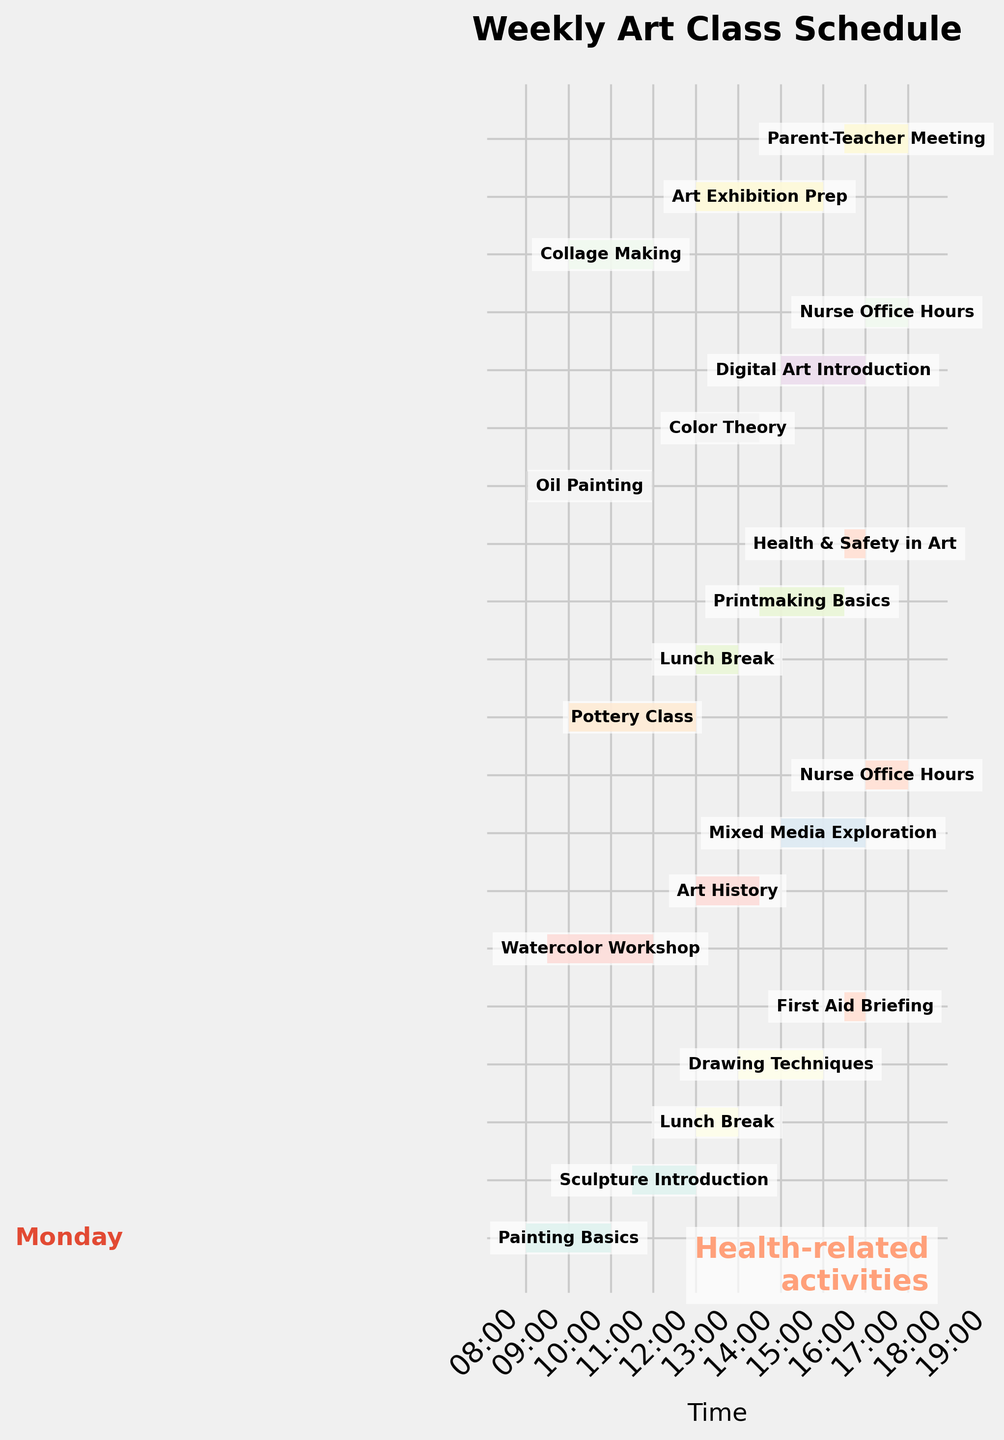What is the title of the figure? The title is typically placed at the top of the figure and describes what the figure represents. Here, the title is clearly stated.
Answer: Weekly Art Class Schedule On which days does the 'Nurse Office Hours' activity occur? We need to locate the 'Nurse Office Hours' bars on the chart and see on which days they are plotted.
Answer: Tuesday, Thursday What is the duration of the 'Pottery Class'? By looking at the length of the bar associated with 'Pottery Class' and the time labels on the x-axis, we can determine its length. The start time is 10:00, and the end time is 13:00.
Answer: 3 hours Which day has the highest number of activities? To determine this, count the number of bars on each day and compare.
Answer: Monday Which activity has the shortest duration? Find the smallest bar length by visually inspecting all the activities. For exact duration, refer to the time labels. 'First Aid Briefing' and 'Health & Safety in Art' have a duration of 0.5 hours each.
Answer: First Aid Briefing and Health & Safety in Art How much total time is allocated for 'health-related activities'? We need to add the durations of 'First Aid Briefing', 'Nurse Office Hours' (both days), and 'Health & Safety in Art': 0.5 + 1 + 1 + 0.5 = 3 hours.
Answer: 3 hours Which activity starts the earliest in the week? Identify the activity with the earliest start time by looking at the leftmost bars of the chart. 'Painting Basics' at 09:00 on Monday is the earliest.
Answer: Painting Basics Does 'Art Exhibition Prep' overlap with any other activity? Check if the 'Art Exhibition Prep' bar intersects with any other bars on Friday. There's no intersection between this and other Friday activities.
Answer: No What is the average duration of all activities on Tuesday? Calculate the average duration: (2.5 + 1.5 + 2 + 1) / 4 = 1.75 hours.
Answer: 1.75 hours Which activity has the latest end time on Wednesday? To find this, locate the activity bar on Wednesday that extends farthest to the right. 'Health & Safety in Art' ends at 17:00.
Answer: Health & Safety in Art 